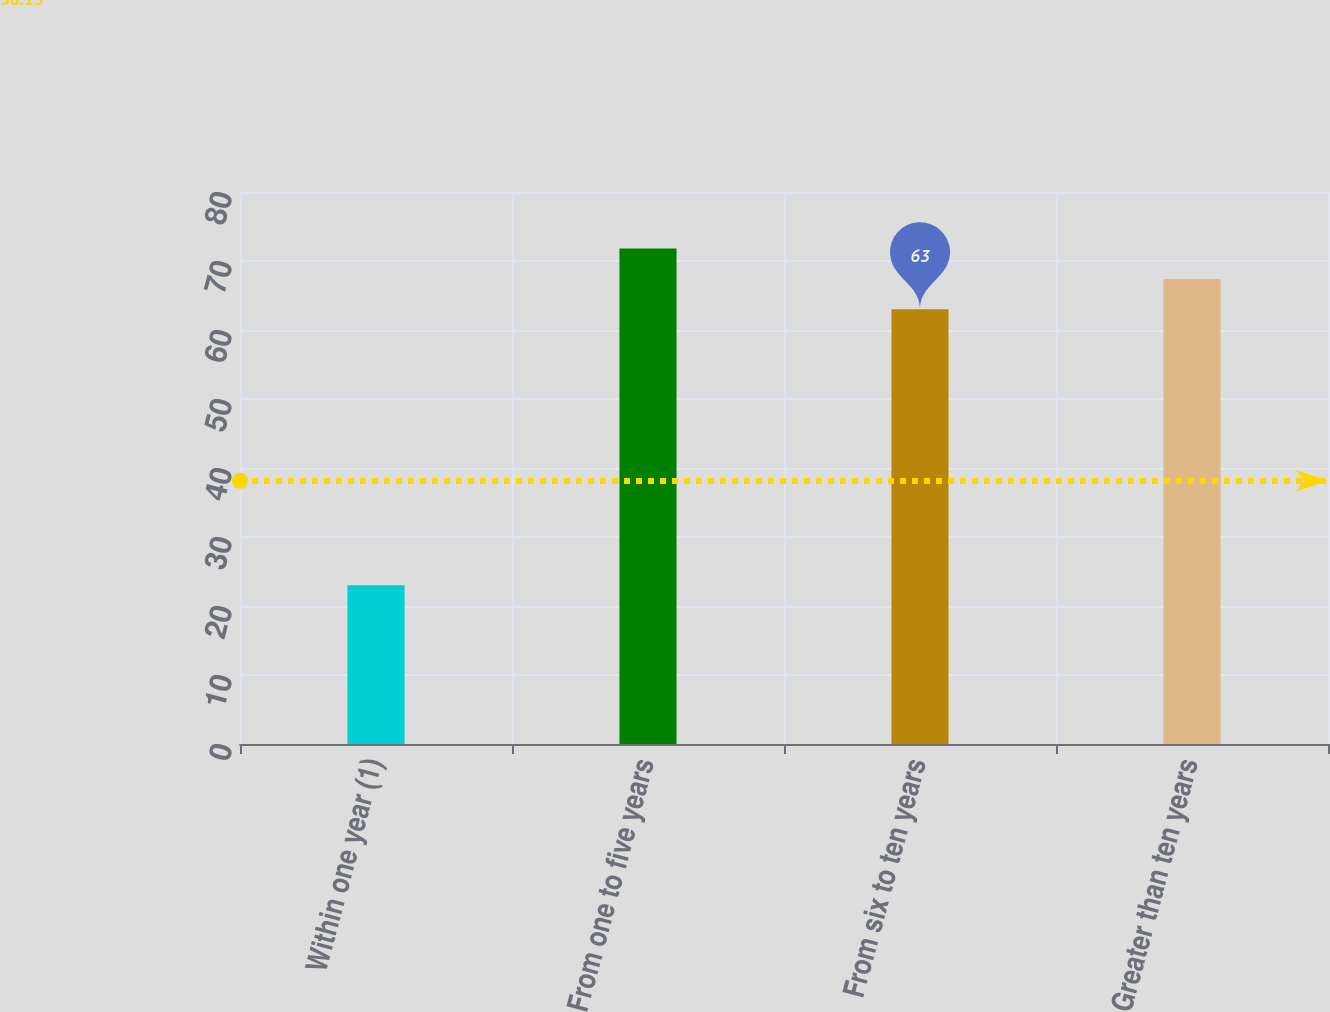<chart> <loc_0><loc_0><loc_500><loc_500><bar_chart><fcel>Within one year (1)<fcel>From one to five years<fcel>From six to ten years<fcel>Greater than ten years<nl><fcel>23<fcel>71.8<fcel>63<fcel>67.4<nl></chart> 